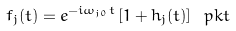<formula> <loc_0><loc_0><loc_500><loc_500>f _ { j } ( t ) = e ^ { - i \omega _ { j 0 } t } \left [ 1 + h _ { j } ( t ) \right ] \ p k t</formula> 